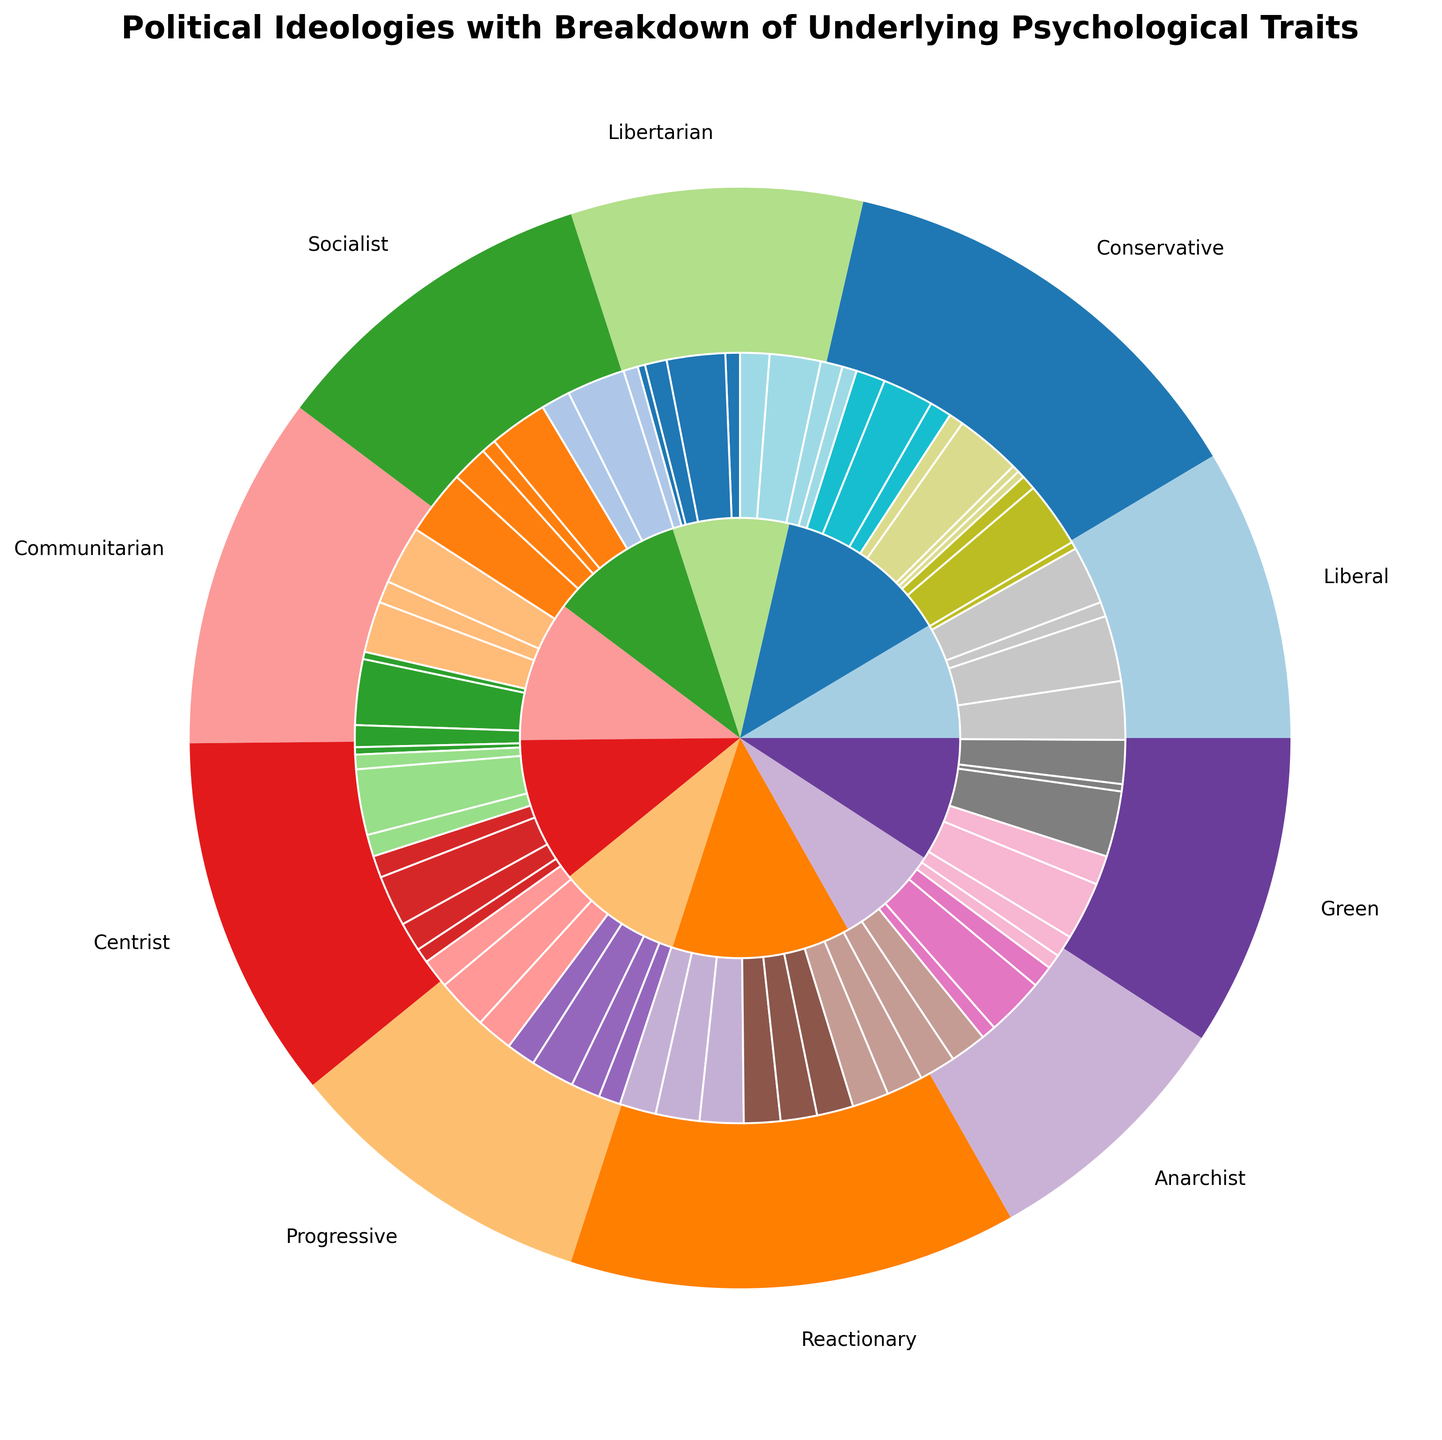What political ideology has the highest level of authoritarianism, and what is that level? First, find the traits associated with each political ideology. Then look for the ideology with the highest value in the authoritarianism section. The Reactionary group has the highest level of authoritarianism at 0.9.
Answer: Reactionary at 0.9 Which political ideology has the lowest openness? Identify the values associated with openness for each political ideology. The ideology with the lowest value is Conservative and Reactionary, both at 0.1.
Answer: Conservative and Reactionary at 0.1 Compare the levels of Tolerance for Ambiguity between Liberals and Conservatives. Which one is higher? Refer to the respective segments for Tolerance for Ambiguity for Liberals and Conservatives. Liberals have a value of 0.8, while Conservatives have 0.3. Therefore, Liberals have a higher value.
Answer: Liberals What's the sum of openness levels for Liberals, Socialists, and Greens? Add the values in the openness category for Liberals (0.8), Socialists (0.7), and Greens (0.7). The total is 0.8 + 0.7 + 0.7 = 2.2.
Answer: 2.2 Among Centrist and Progressive, who shows a higher need for cognitive closure and by what difference? Look for the Need for Cognitive Closure values for both Centrist (0.5) and Progressive (0.4). Calculate the difference: 0.5 - 0.4 = 0.1.
Answer: Centrist by 0.1 What color represents Liberals, and what psychological trait does this color mainly correspond to in the chart? Find the outer pie segment's color for Liberal and then identify the corresponding segment in the inner pie chart. Observe where this color mainly appears. The Liberals are represented by a light blue shade which is mainly associated with Openness.
Answer: Light blue, Openness Of all political ideologies, which has the most balanced (almost equal) distribution of psychological traits and what are the numerical values? Look for the political ideology where values across all psychological traits are nearly equal. The Centrist ideology has a balanced distribution with all values being 0.5.
Answer: Centrist with all values at 0.5 Which ideology has the highest cognitive dissonance and what is the level? Check the Cognitive Dissonance section for each ideology and find the highest value. The Reactionary ideology has the highest cognitive dissonance at 0.6.
Answer: Reactionary at 0.6 Which ideology shows equal values for both Dogmatism and Tolerance for Ambiguity, and what are these values? Identify the ideologies where the values for Dogmatism are the same as Tolerance for Ambiguity. The Socialist and the Green ideologies both have Dogmatism and Tolerance for Ambiguity at 0.4 and 0.7 respectively for Green.
Answer: Socialist at 0.4, Green at 0.7 